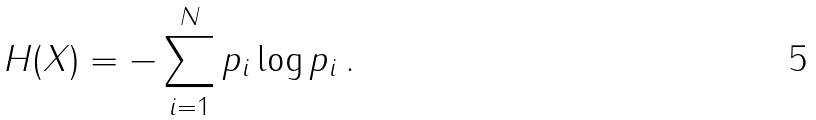<formula> <loc_0><loc_0><loc_500><loc_500>H ( X ) = - \sum _ { i = 1 } ^ { N } p _ { i } \log p _ { i } \, .</formula> 